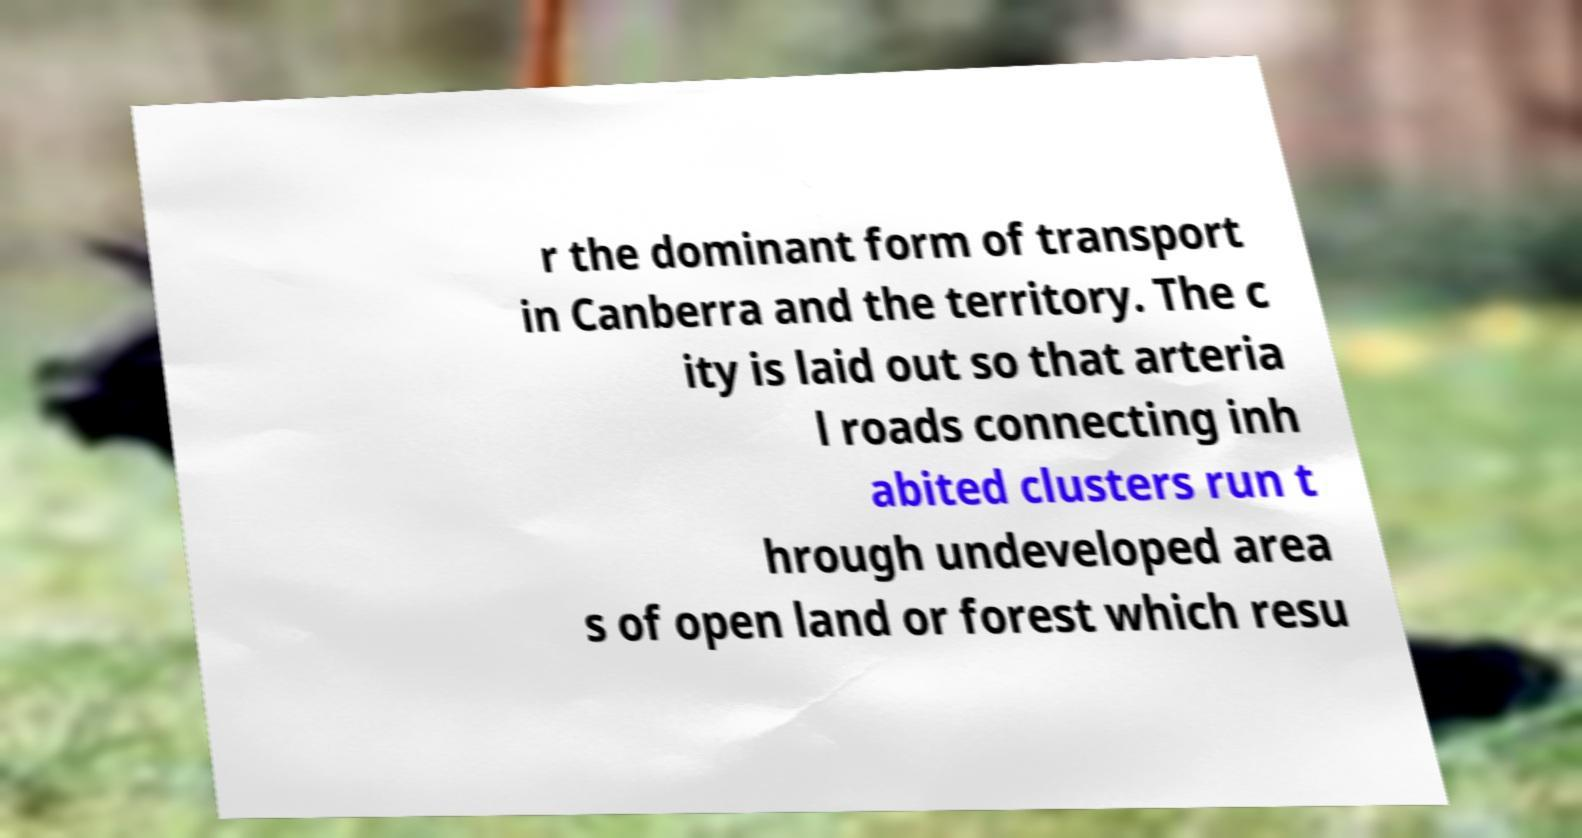Could you extract and type out the text from this image? r the dominant form of transport in Canberra and the territory. The c ity is laid out so that arteria l roads connecting inh abited clusters run t hrough undeveloped area s of open land or forest which resu 